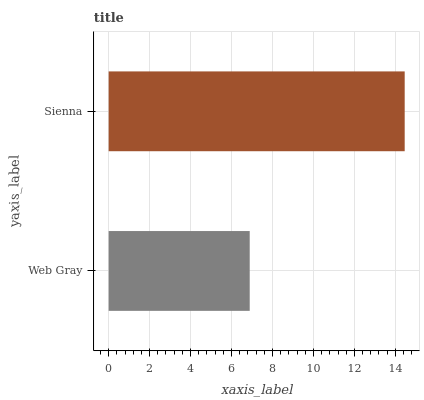Is Web Gray the minimum?
Answer yes or no. Yes. Is Sienna the maximum?
Answer yes or no. Yes. Is Sienna the minimum?
Answer yes or no. No. Is Sienna greater than Web Gray?
Answer yes or no. Yes. Is Web Gray less than Sienna?
Answer yes or no. Yes. Is Web Gray greater than Sienna?
Answer yes or no. No. Is Sienna less than Web Gray?
Answer yes or no. No. Is Sienna the high median?
Answer yes or no. Yes. Is Web Gray the low median?
Answer yes or no. Yes. Is Web Gray the high median?
Answer yes or no. No. Is Sienna the low median?
Answer yes or no. No. 